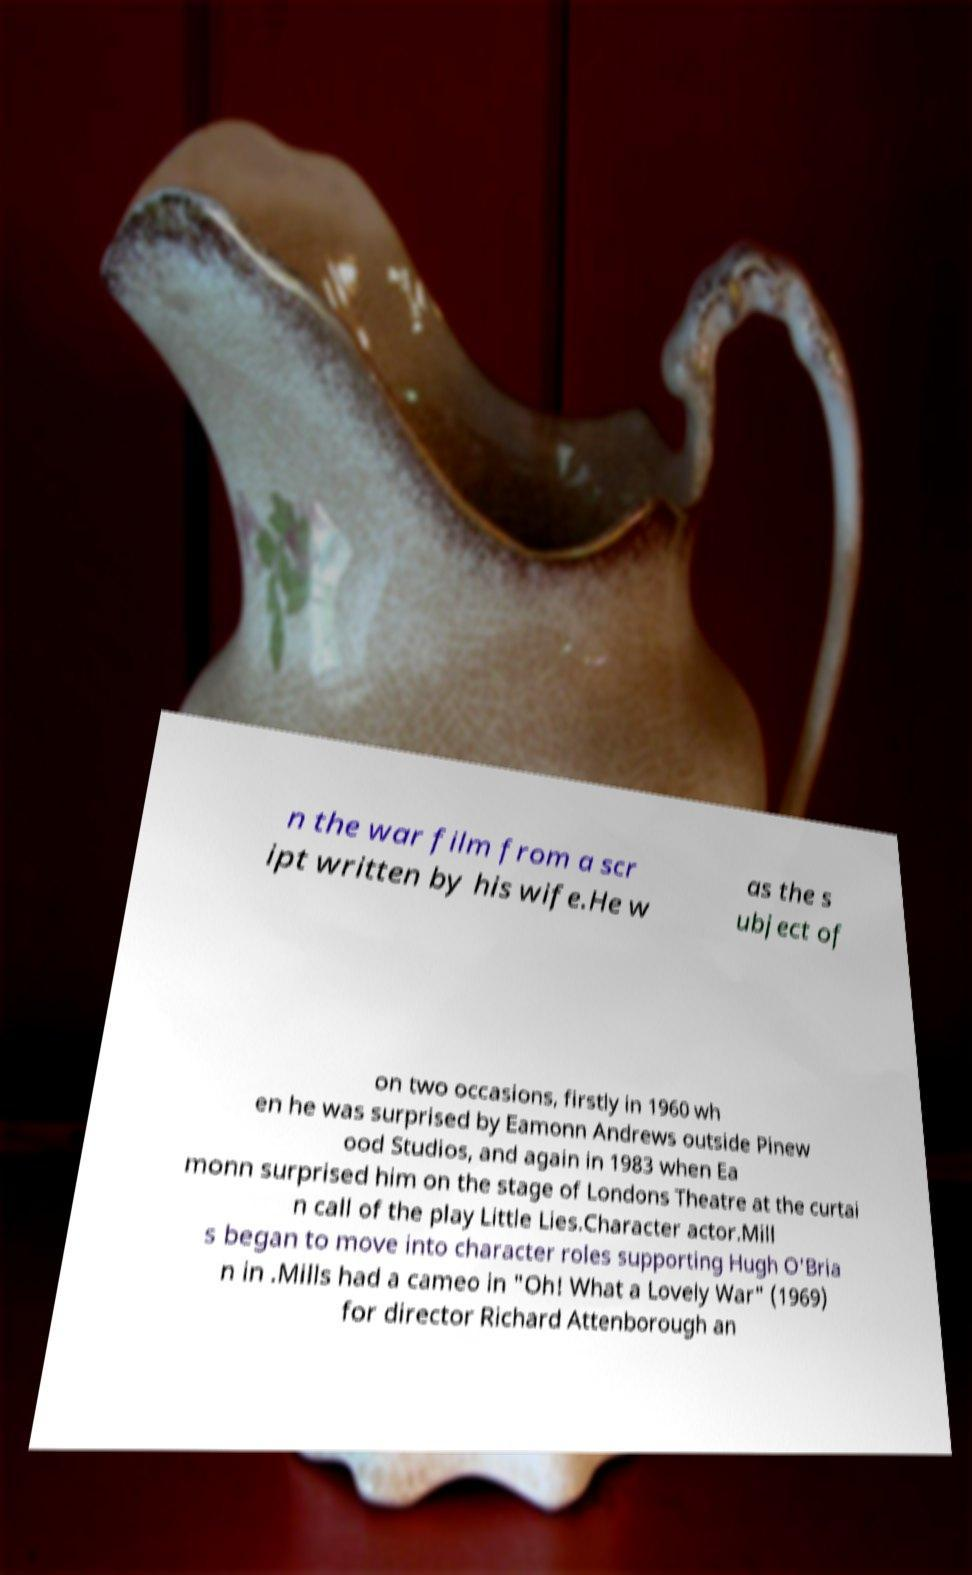I need the written content from this picture converted into text. Can you do that? n the war film from a scr ipt written by his wife.He w as the s ubject of on two occasions, firstly in 1960 wh en he was surprised by Eamonn Andrews outside Pinew ood Studios, and again in 1983 when Ea monn surprised him on the stage of Londons Theatre at the curtai n call of the play Little Lies.Character actor.Mill s began to move into character roles supporting Hugh O'Bria n in .Mills had a cameo in "Oh! What a Lovely War" (1969) for director Richard Attenborough an 